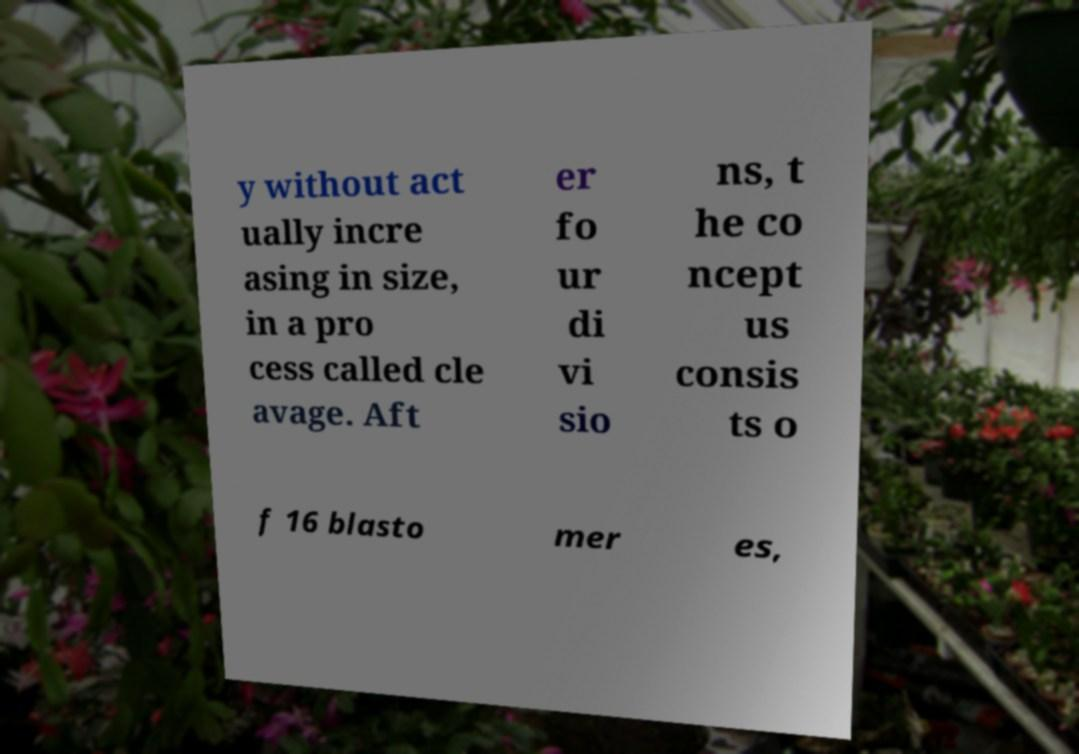Please identify and transcribe the text found in this image. y without act ually incre asing in size, in a pro cess called cle avage. Aft er fo ur di vi sio ns, t he co ncept us consis ts o f 16 blasto mer es, 